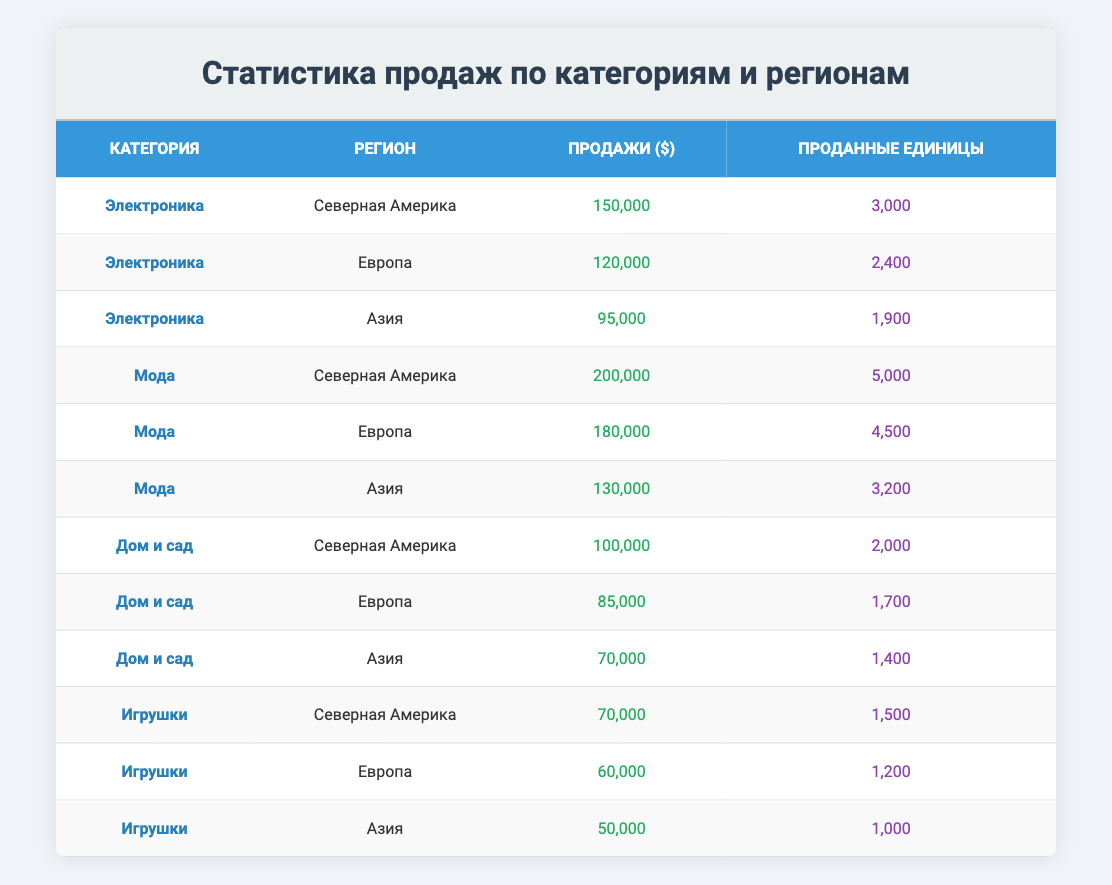What are the total sales for the Fashion category in North America? The sales for the Fashion category in North America are listed directly in the table as 200,000.
Answer: 200000 Which region has the highest sales in the Electronics category? By comparing the sales figures in the Electronics category for all regions, North America has the highest sales at 150,000, followed by Europe at 120,000 and Asia at 95,000.
Answer: North America What is the average number of units sold across all categories in Asia? The total number of units sold in Asia is 1,900 (Electronics) + 3,200 (Fashion) + 1,400 (Home & Garden) + 1,000 (Toys) = 7,500. There are four data points, so the average is 7,500 / 4 = 1,875.
Answer: 1875 Is it true that Home & Garden has lower sales than Toys in Europe? The sales for Home & Garden in Europe are 85,000 while the sales for Toys in Europe are 60,000. Since 85,000 is greater than 60,000, this statement is false.
Answer: No What is the total sales for the Electronics category across all regions? The sales for the Electronics category are 150,000 (North America) + 120,000 (Europe) + 95,000 (Asia) = 365,000.
Answer: 365000 In which region did Home & Garden category sell the least? Comparing the sales for Home & Garden across the three regions: 100,000 (North America), 85,000 (Europe), and 70,000 (Asia), it is clear that the least sales occurred in Asia with 70,000.
Answer: Asia What is the difference in units sold between the Fashion category in North America and the Electronics category in Asia? The units sold for Fashion in North America are 5,000 and for Electronics in Asia are 1,900. The difference is 5,000 - 1,900 = 3,100.
Answer: 3100 Which category had the highest total sales in Europe? The total sales in Europe are 120,000 (Electronics), 180,000 (Fashion), 85,000 (Home & Garden), and 60,000 (Toys). Thus, Fashion with 180,000 has the highest total sales.
Answer: Fashion 